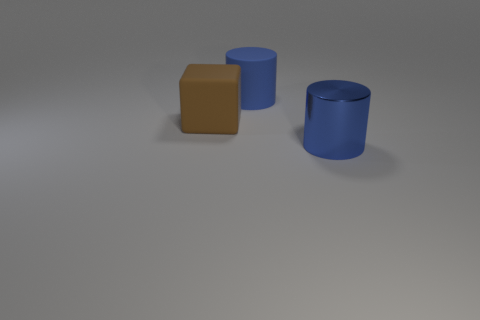Subtract all green cubes. Subtract all yellow cylinders. How many cubes are left? 1 Add 1 cylinders. How many objects exist? 4 Subtract all cylinders. How many objects are left? 1 Subtract all small cyan metal cylinders. Subtract all large brown blocks. How many objects are left? 2 Add 3 large shiny cylinders. How many large shiny cylinders are left? 4 Add 3 blue things. How many blue things exist? 5 Subtract 0 green spheres. How many objects are left? 3 